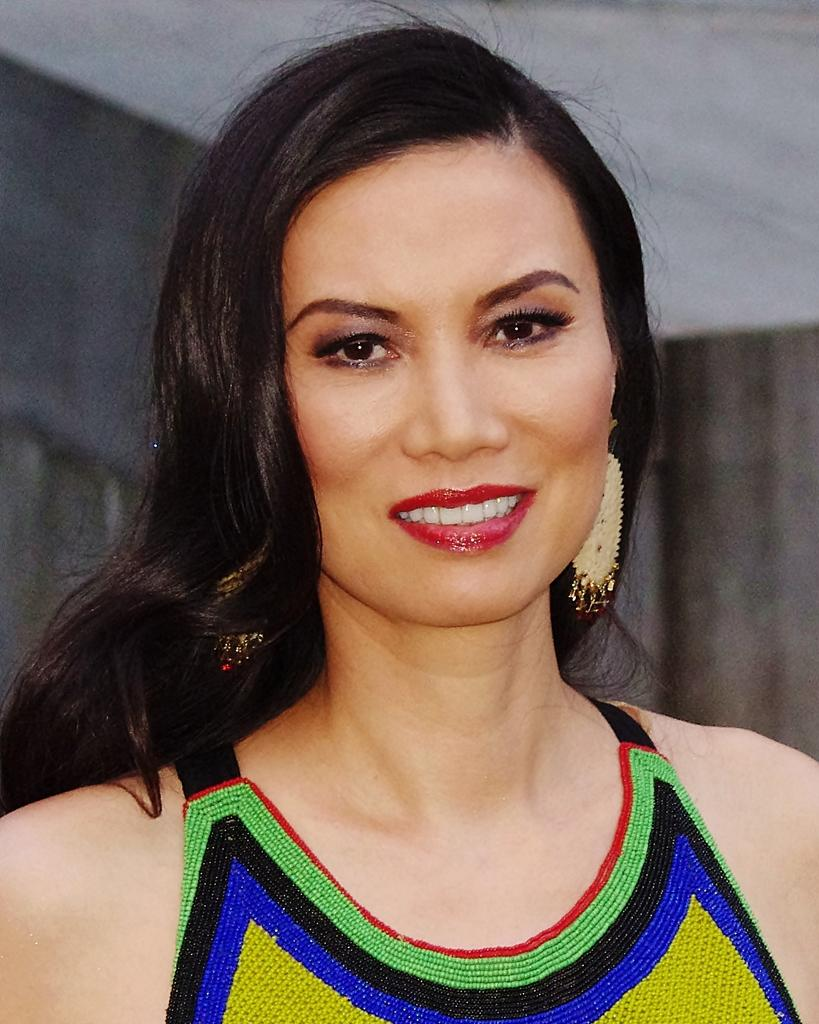Who is the main subject in the picture? There is a girl in the picture. What is the girl doing in the picture? The girl is standing in the picture. What is the girl's facial expression in the picture? The girl is smiling in the picture. What direction is the girl looking in the picture? The girl is looking straight in the picture. What type of hydrant can be seen in the background of the picture? There is no hydrant present in the background of the picture. 